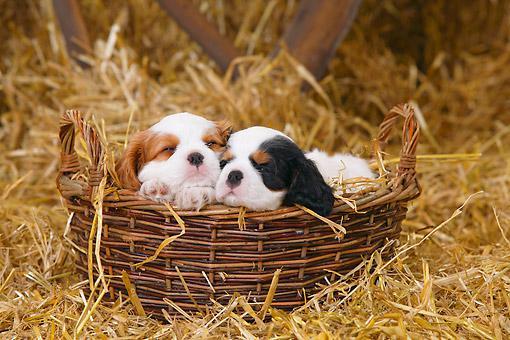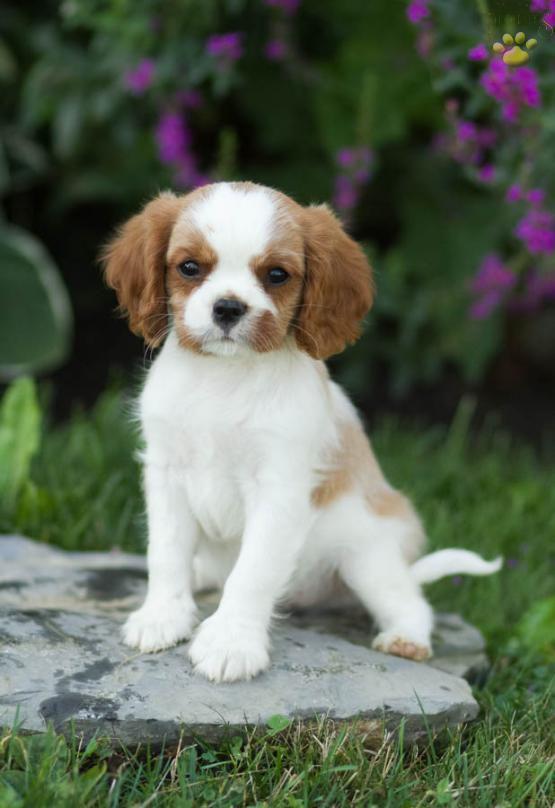The first image is the image on the left, the second image is the image on the right. Examine the images to the left and right. Is the description "In the left image, there is no less than two dogs in a woven basket, and in the right image there is a single brown and white dog" accurate? Answer yes or no. Yes. The first image is the image on the left, the second image is the image on the right. Examine the images to the left and right. Is the description "The left image contains at least three dogs." accurate? Answer yes or no. No. 